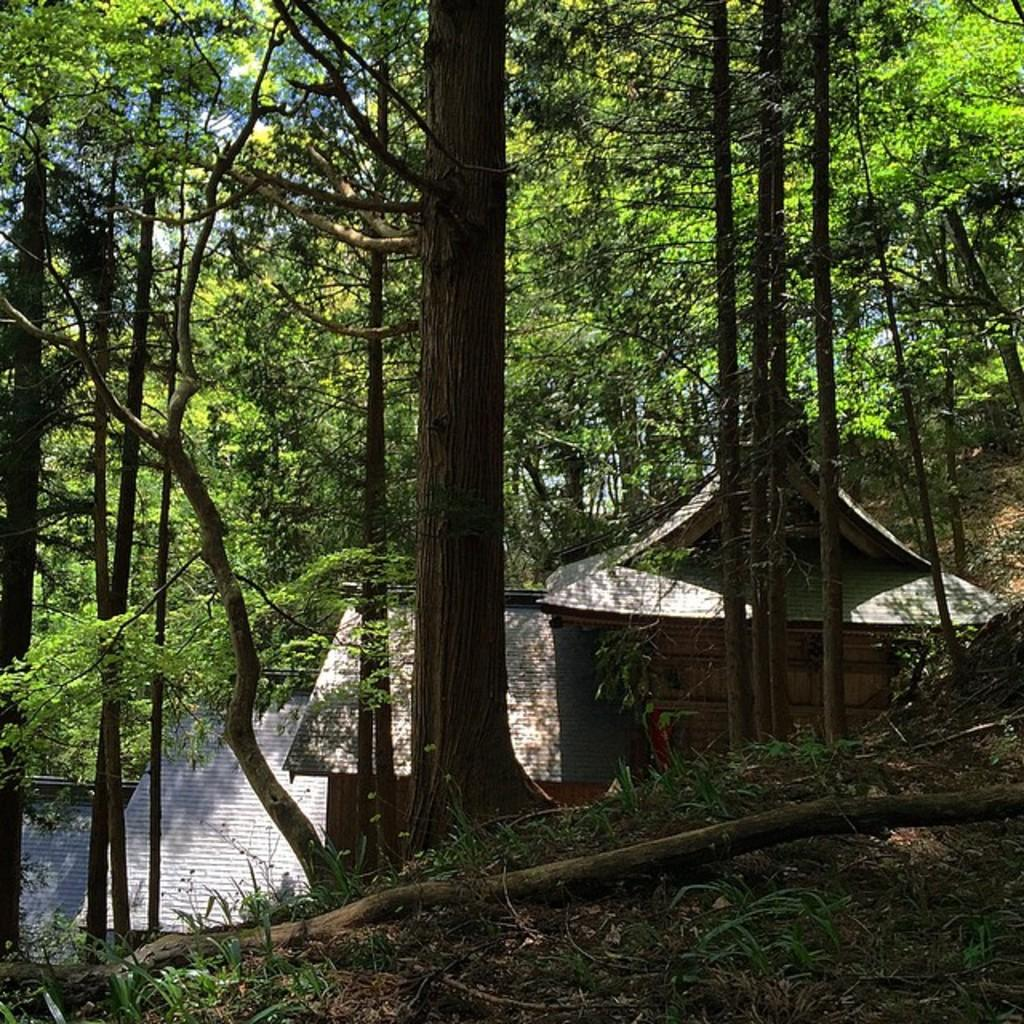What type of vegetation can be seen in the image? There are trees in the image. What structure is located in the middle of the image? There appears to be a house in the middle of the image. What is visible in the background of the image? The sky is visible in the background of the image. Can you tell me how many friends are sitting on the branch in the image? There are no friends or branches present in the image; it features trees and a house. What type of wine is being served in the image? There is no wine present in the image. 